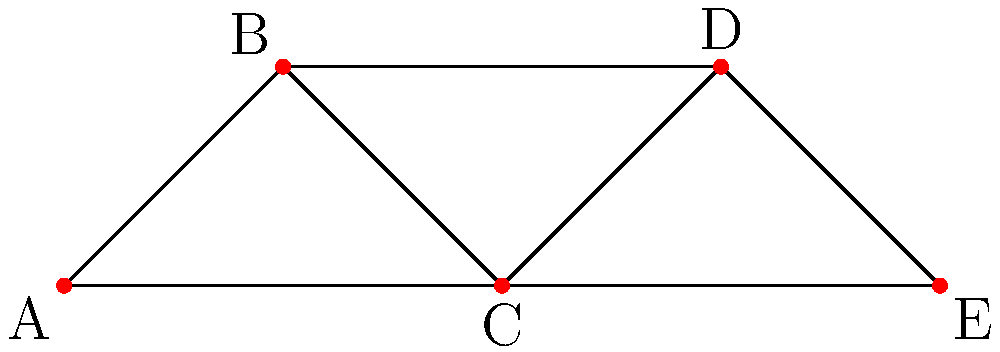Identify the critical node in this supply chain network that, if removed, would cause the most significant disruption to the overall logistics flow. Justify your answer concisely. 1. Analyze node connectivity:
   A: connected to 2 nodes
   B: connected to 2 nodes
   C: connected to 4 nodes
   D: connected to 2 nodes
   E: connected to 2 nodes

2. Identify the node with highest connectivity: Node C

3. Assess impact of removing Node C:
   - Disconnects A and E from B and D
   - Creates two separate subgraphs
   - Eliminates all paths between left and right sides of the network

4. Compare to other nodes:
   - Removing any other node would not divide the network as severely
   - Other nodes have fewer connections, thus less impact if removed

5. Conclusion: Node C is the critical node, as its removal would cause the most significant disruption by completely separating two parts of the network.
Answer: Node C 